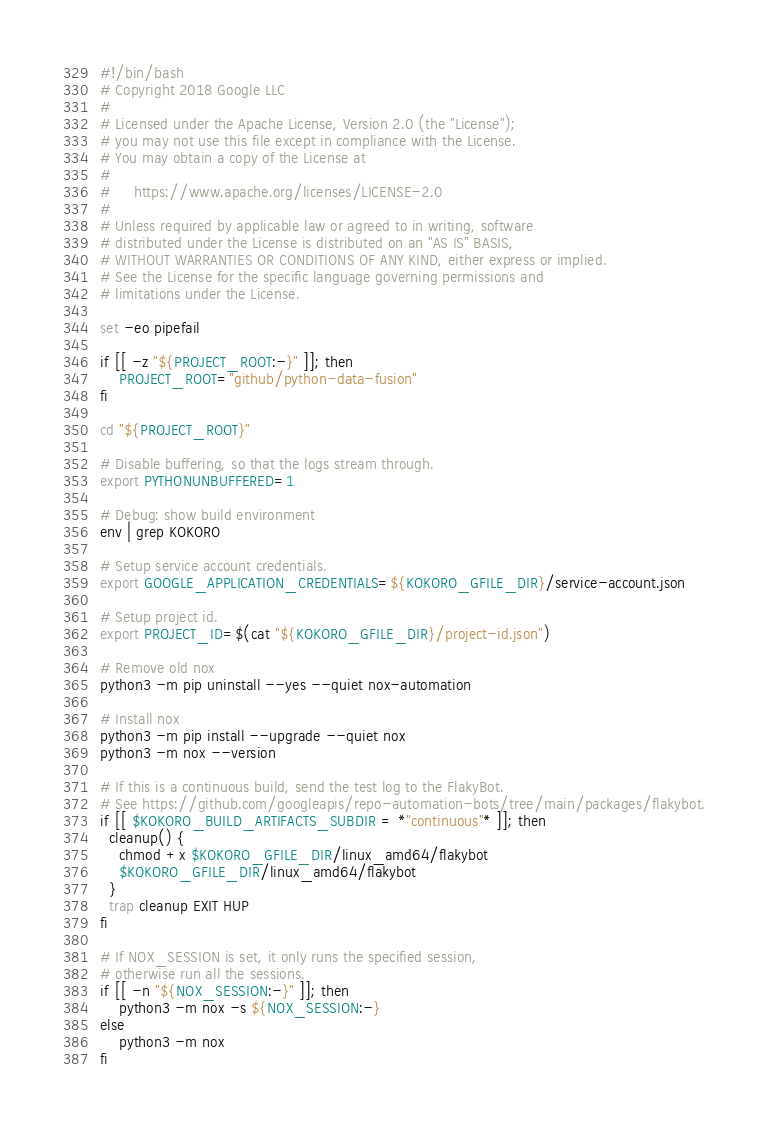<code> <loc_0><loc_0><loc_500><loc_500><_Bash_>#!/bin/bash
# Copyright 2018 Google LLC
#
# Licensed under the Apache License, Version 2.0 (the "License");
# you may not use this file except in compliance with the License.
# You may obtain a copy of the License at
#
#     https://www.apache.org/licenses/LICENSE-2.0
#
# Unless required by applicable law or agreed to in writing, software
# distributed under the License is distributed on an "AS IS" BASIS,
# WITHOUT WARRANTIES OR CONDITIONS OF ANY KIND, either express or implied.
# See the License for the specific language governing permissions and
# limitations under the License.

set -eo pipefail

if [[ -z "${PROJECT_ROOT:-}" ]]; then
    PROJECT_ROOT="github/python-data-fusion"
fi

cd "${PROJECT_ROOT}"

# Disable buffering, so that the logs stream through.
export PYTHONUNBUFFERED=1

# Debug: show build environment
env | grep KOKORO

# Setup service account credentials.
export GOOGLE_APPLICATION_CREDENTIALS=${KOKORO_GFILE_DIR}/service-account.json

# Setup project id.
export PROJECT_ID=$(cat "${KOKORO_GFILE_DIR}/project-id.json")

# Remove old nox
python3 -m pip uninstall --yes --quiet nox-automation

# Install nox
python3 -m pip install --upgrade --quiet nox
python3 -m nox --version

# If this is a continuous build, send the test log to the FlakyBot.
# See https://github.com/googleapis/repo-automation-bots/tree/main/packages/flakybot.
if [[ $KOKORO_BUILD_ARTIFACTS_SUBDIR = *"continuous"* ]]; then
  cleanup() {
    chmod +x $KOKORO_GFILE_DIR/linux_amd64/flakybot
    $KOKORO_GFILE_DIR/linux_amd64/flakybot
  }
  trap cleanup EXIT HUP
fi

# If NOX_SESSION is set, it only runs the specified session,
# otherwise run all the sessions.
if [[ -n "${NOX_SESSION:-}" ]]; then
    python3 -m nox -s ${NOX_SESSION:-}
else
    python3 -m nox
fi
</code> 